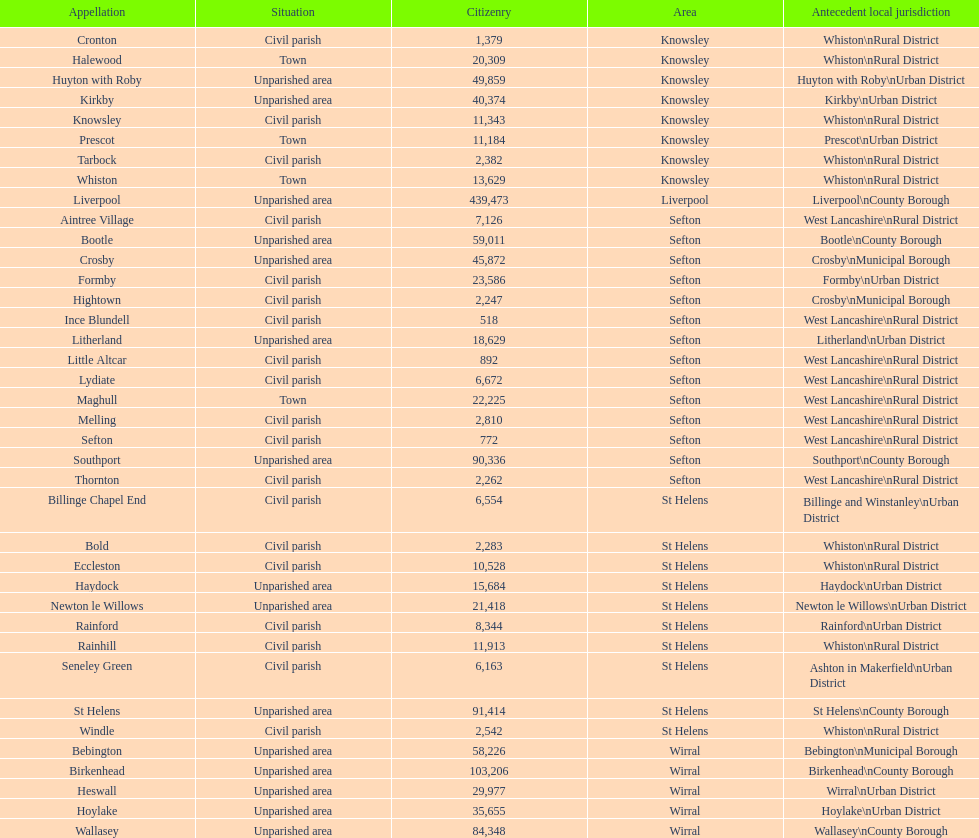Which is a civil parish, aintree village or maghull? Aintree Village. 